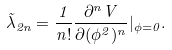<formula> <loc_0><loc_0><loc_500><loc_500>\tilde { \lambda } _ { 2 n } = \frac { 1 } { n ! } \frac { \partial ^ { n } V } { \partial ( \phi ^ { 2 } ) ^ { n } } | _ { \phi = 0 } .</formula> 